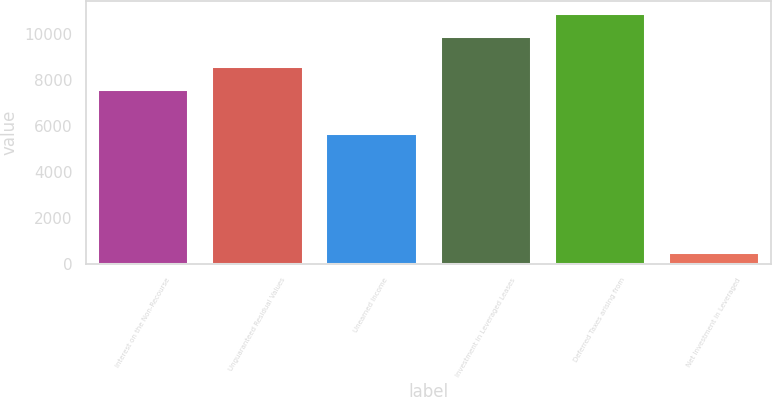Convert chart. <chart><loc_0><loc_0><loc_500><loc_500><bar_chart><fcel>Interest on the Non-Recourse<fcel>Unguaranteed Residual Values<fcel>Unearned Income<fcel>Investment in Leveraged Leases<fcel>Deferred Taxes arising from<fcel>Net Investment in Leveraged<nl><fcel>7591<fcel>8581.1<fcel>5702<fcel>9901<fcel>10891.1<fcel>519<nl></chart> 